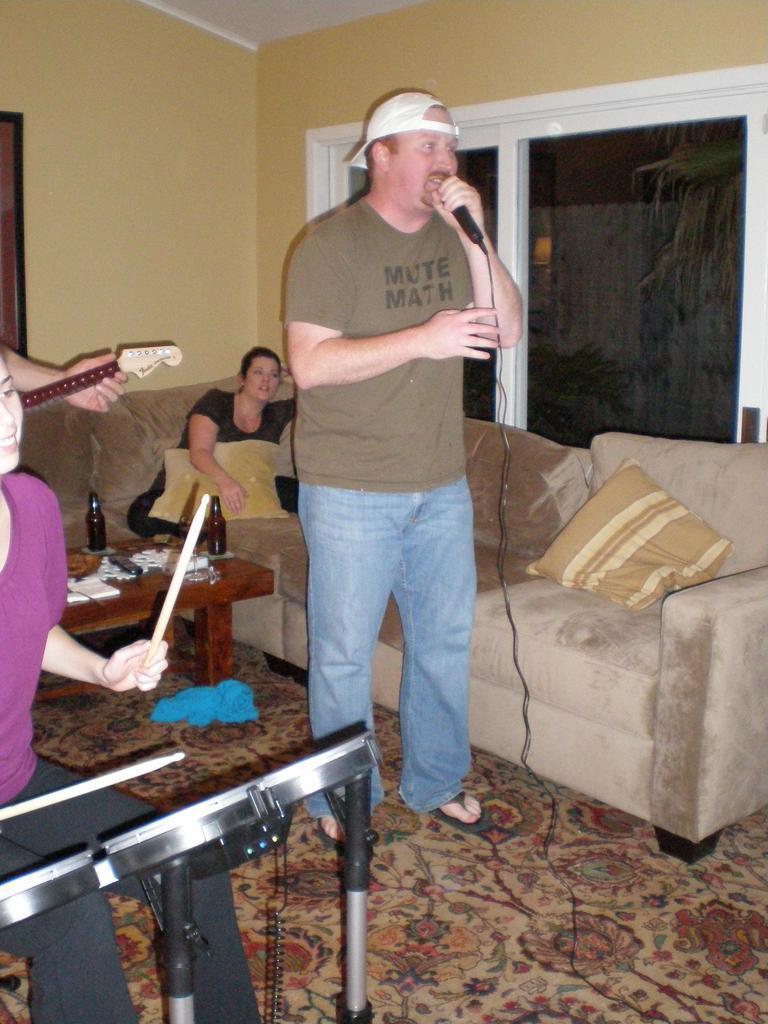Can you describe this image briefly? In this Image I see 4 persons, in which this man is standing and holding a mic and this woman is holding sticks and is in front of a musical instrument and I see a person with guitar and this woman is sitting on the sofa, I can also see there is a table over here on which there are bottles and other things. In the background I see the wall and the window. 